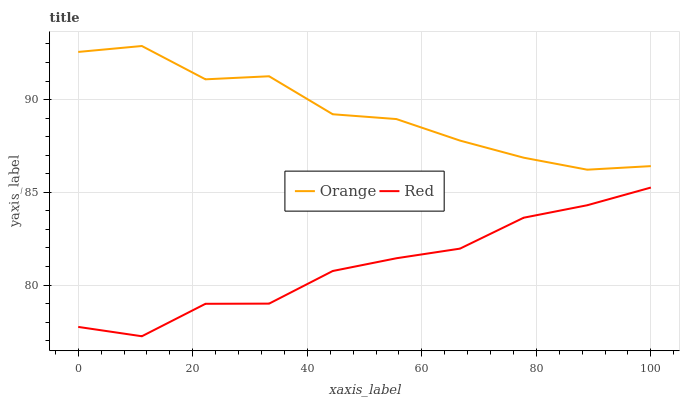Does Red have the minimum area under the curve?
Answer yes or no. Yes. Does Orange have the maximum area under the curve?
Answer yes or no. Yes. Does Red have the maximum area under the curve?
Answer yes or no. No. Is Red the smoothest?
Answer yes or no. Yes. Is Orange the roughest?
Answer yes or no. Yes. Is Red the roughest?
Answer yes or no. No. Does Red have the lowest value?
Answer yes or no. Yes. Does Orange have the highest value?
Answer yes or no. Yes. Does Red have the highest value?
Answer yes or no. No. Is Red less than Orange?
Answer yes or no. Yes. Is Orange greater than Red?
Answer yes or no. Yes. Does Red intersect Orange?
Answer yes or no. No. 